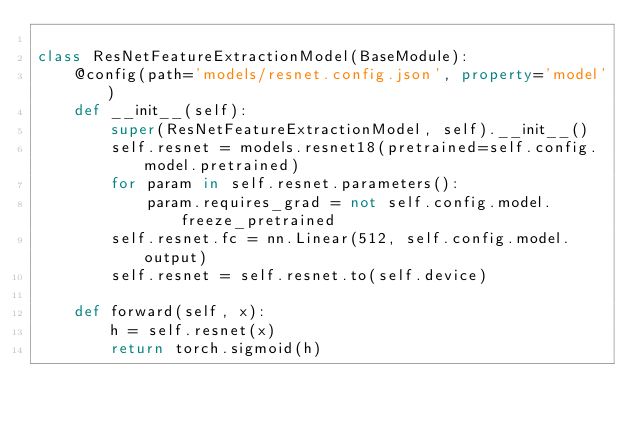<code> <loc_0><loc_0><loc_500><loc_500><_Python_>
class ResNetFeatureExtractionModel(BaseModule):
    @config(path='models/resnet.config.json', property='model')
    def __init__(self):
        super(ResNetFeatureExtractionModel, self).__init__()
        self.resnet = models.resnet18(pretrained=self.config.model.pretrained)
        for param in self.resnet.parameters():
            param.requires_grad = not self.config.model.freeze_pretrained
        self.resnet.fc = nn.Linear(512, self.config.model.output)
        self.resnet = self.resnet.to(self.device)

    def forward(self, x):
        h = self.resnet(x)
        return torch.sigmoid(h)
</code> 